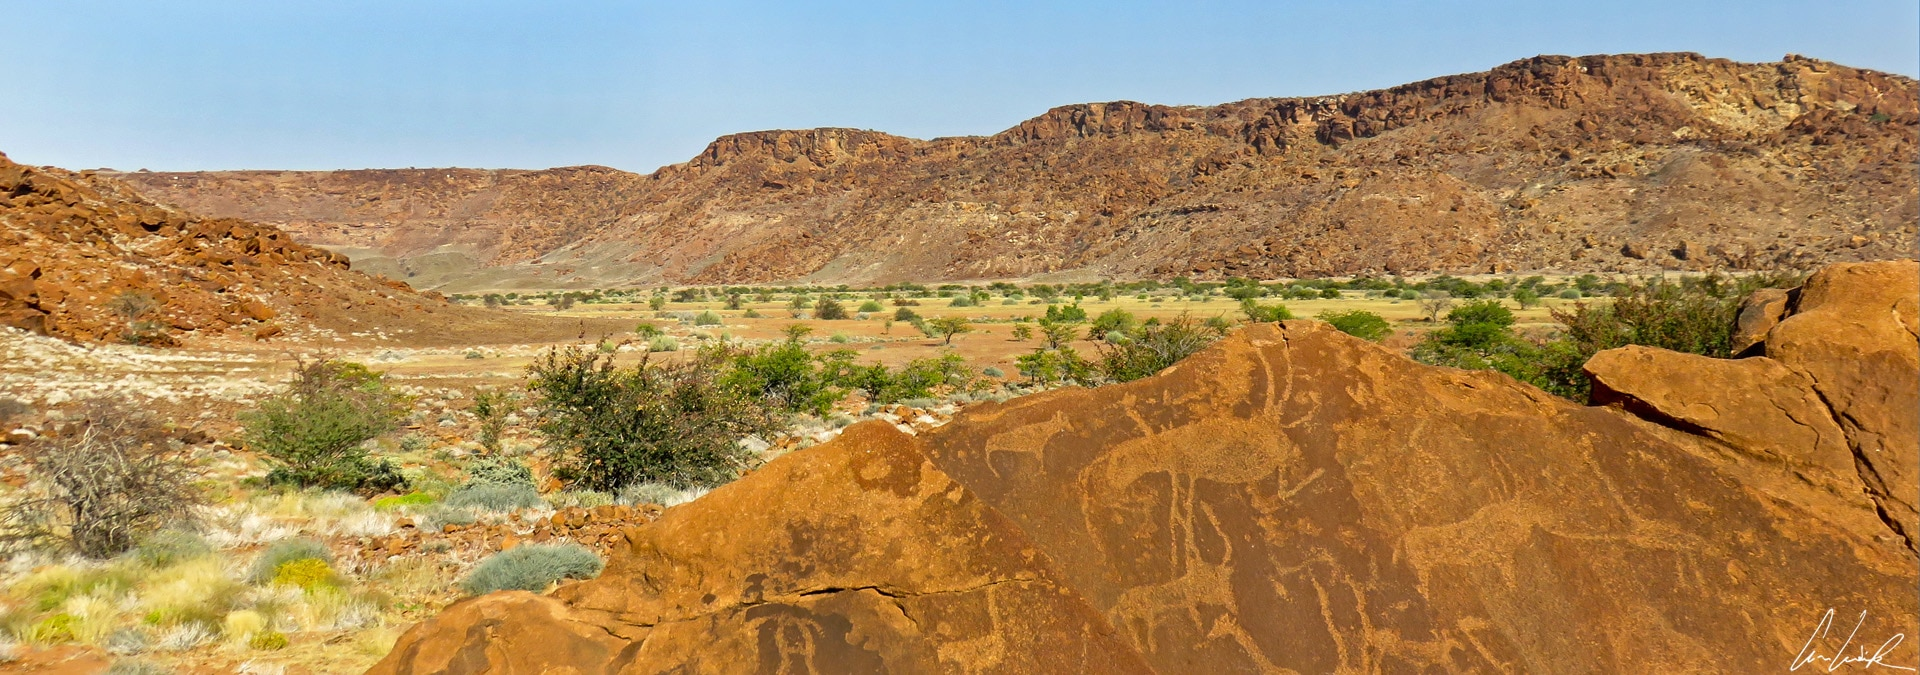Can you explain the significance of the Twyfelfontein? Why is it considered a UNESCO World Heritage Site? Twyfelfontein is one of Africa’s largest and most important concentrations of rock art, boasting around 2,500 individual engravings. These petroglyphs, some more than 6,000 years old, offer a fascinating glimpse into the lives and cosmology of ancient hunter-gatherer communities who inhabited the region. The site's significance extends beyond its artistic value, as it represents a vital cultural and historical record of human expression and adaptation in one of the world’s harshest environments. Its designation as a UNESCO World Heritage Site underscores its exceptional value to humanity, preserving these irreplaceable artworks for future generations and highlighting the universal heritage they represent. 